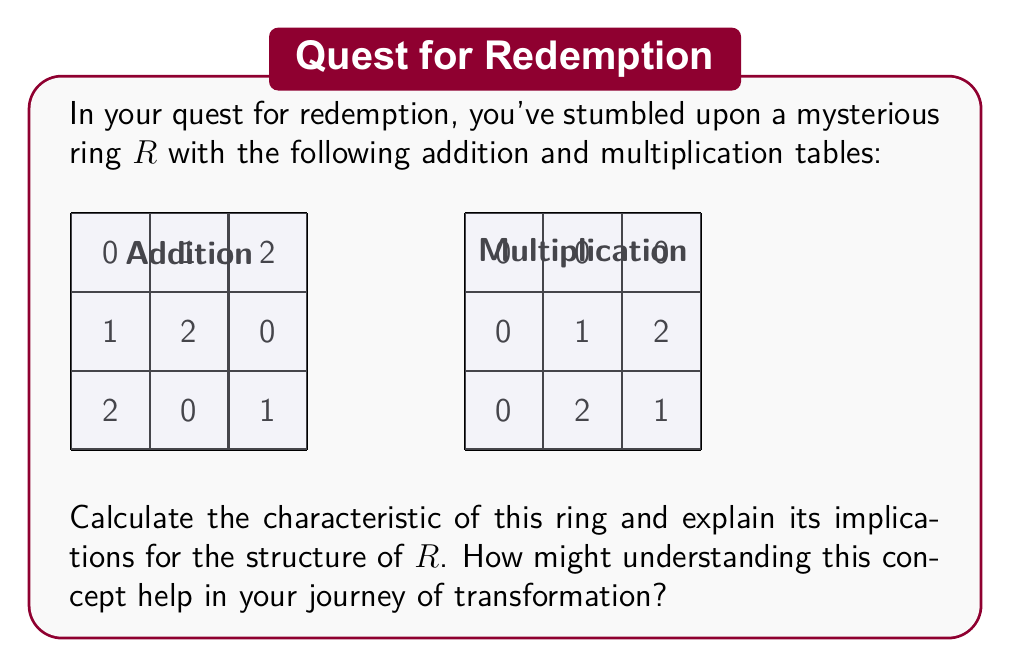Can you solve this math problem? To calculate the characteristic of the ring $R$ and understand its implications, let's follow these steps:

1) The characteristic of a ring is the smallest positive integer $n$ such that $n \cdot 1 = 0$, where $1$ is the multiplicative identity of the ring. If no such positive integer exists, the characteristic is 0.

2) From the multiplication table, we can see that $1$ is the multiplicative identity of $R$.

3) Let's calculate $n \cdot 1$ for increasing values of $n$:
   
   $1 \cdot 1 = 1$
   $2 \cdot 1 = 1 + 1 = 2$
   $3 \cdot 1 = 1 + 1 + 1 = 0$ (using the addition table)

4) We see that $3 \cdot 1 = 0$, and this is the smallest positive integer with this property.

5) Therefore, the characteristic of the ring $R$ is 3.

Implications:

1) The ring $R$ is a finite ring with 3 elements.

2) In a ring of characteristic 3, the equation $x + x + x = 0$ holds for all elements $x$ in the ring.

3) The ring $R$ is isomorphic to the ring $\mathbb{Z}/3\mathbb{Z}$ (integers modulo 3).

4) All elements of $R$ satisfy the equation $x^3 = x$ (Fermat's Little Theorem for characteristic 3).

Understanding ring characteristics can help in your journey of transformation by:

1) Illustrating that even complex systems (like rings) have fundamental properties (like characteristic) that define their behavior.

2) Showing how small, finite structures can model larger, infinite ones (e.g., $R$ models aspects of modular arithmetic).

3) Demonstrating that understanding the underlying rules of a system can lead to insights about its overall structure and behavior, much like understanding the consequences of one's actions can lead to personal growth and redemption.
Answer: Characteristic: 3. Implications: Finite ring with 3 elements, isomorphic to $\mathbb{Z}/3\mathbb{Z}$, all elements $x$ satisfy $x^3 = x$ and $x + x + x = 0$. 